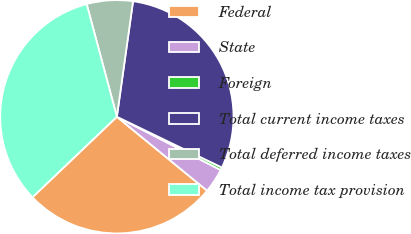Convert chart to OTSL. <chart><loc_0><loc_0><loc_500><loc_500><pie_chart><fcel>Federal<fcel>State<fcel>Foreign<fcel>Total current income taxes<fcel>Total deferred income taxes<fcel>Total income tax provision<nl><fcel>26.95%<fcel>3.38%<fcel>0.38%<fcel>29.95%<fcel>6.38%<fcel>32.96%<nl></chart> 